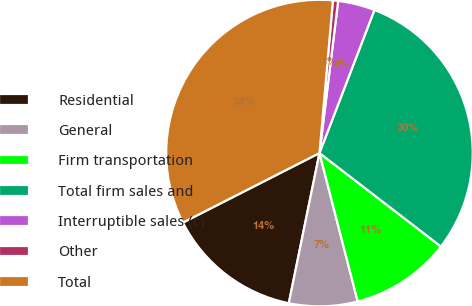Convert chart. <chart><loc_0><loc_0><loc_500><loc_500><pie_chart><fcel>Residential<fcel>General<fcel>Firm transportation<fcel>Total firm sales and<fcel>Interruptible sales (c)<fcel>Other<fcel>Total<nl><fcel>14.3%<fcel>7.22%<fcel>10.55%<fcel>29.6%<fcel>3.89%<fcel>0.55%<fcel>33.89%<nl></chart> 